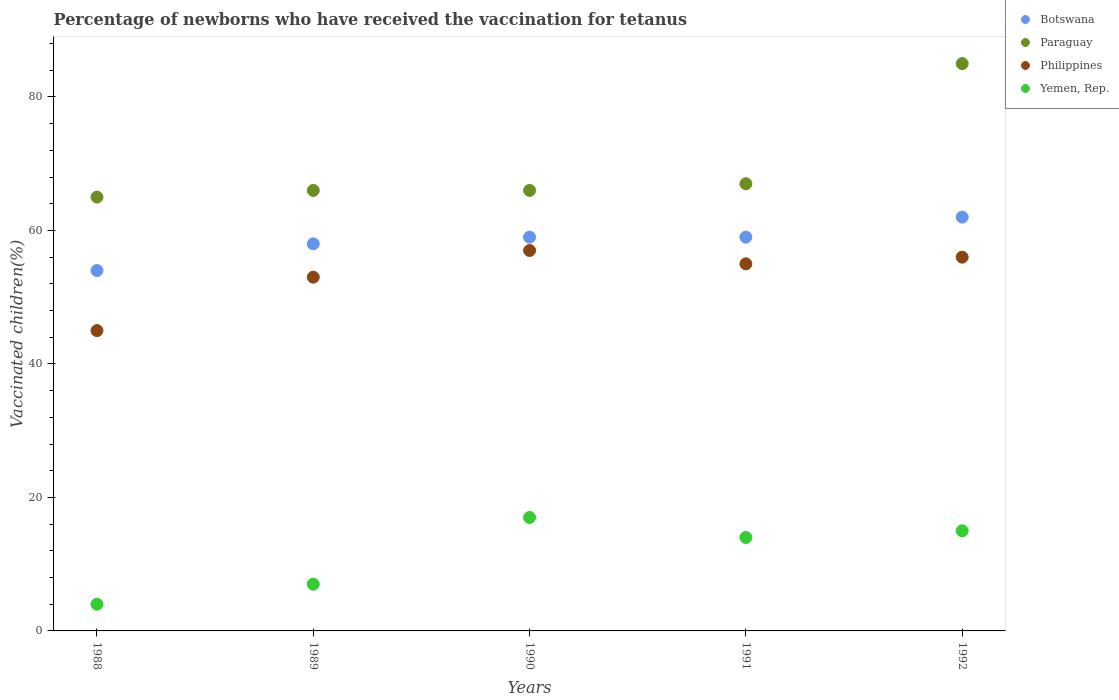Across all years, what is the maximum percentage of vaccinated children in Philippines?
Offer a terse response. 57. Across all years, what is the minimum percentage of vaccinated children in Paraguay?
Your response must be concise. 65. In which year was the percentage of vaccinated children in Philippines maximum?
Your answer should be compact. 1990. In which year was the percentage of vaccinated children in Botswana minimum?
Make the answer very short. 1988. What is the total percentage of vaccinated children in Philippines in the graph?
Give a very brief answer. 266. What is the difference between the percentage of vaccinated children in Philippines in 1988 and that in 1992?
Keep it short and to the point. -11. What is the difference between the percentage of vaccinated children in Paraguay in 1988 and the percentage of vaccinated children in Yemen, Rep. in 1992?
Keep it short and to the point. 50. What is the average percentage of vaccinated children in Philippines per year?
Provide a succinct answer. 53.2. What is the ratio of the percentage of vaccinated children in Botswana in 1988 to that in 1989?
Offer a very short reply. 0.93. What is the difference between the highest and the second highest percentage of vaccinated children in Yemen, Rep.?
Your answer should be very brief. 2. What is the difference between the highest and the lowest percentage of vaccinated children in Yemen, Rep.?
Your response must be concise. 13. In how many years, is the percentage of vaccinated children in Botswana greater than the average percentage of vaccinated children in Botswana taken over all years?
Your answer should be very brief. 3. Is it the case that in every year, the sum of the percentage of vaccinated children in Yemen, Rep. and percentage of vaccinated children in Botswana  is greater than the sum of percentage of vaccinated children in Paraguay and percentage of vaccinated children in Philippines?
Your answer should be compact. No. Is it the case that in every year, the sum of the percentage of vaccinated children in Paraguay and percentage of vaccinated children in Philippines  is greater than the percentage of vaccinated children in Botswana?
Provide a short and direct response. Yes. Does the percentage of vaccinated children in Paraguay monotonically increase over the years?
Offer a terse response. No. Is the percentage of vaccinated children in Paraguay strictly less than the percentage of vaccinated children in Botswana over the years?
Make the answer very short. No. How many years are there in the graph?
Provide a succinct answer. 5. Are the values on the major ticks of Y-axis written in scientific E-notation?
Give a very brief answer. No. Does the graph contain grids?
Ensure brevity in your answer.  No. What is the title of the graph?
Ensure brevity in your answer.  Percentage of newborns who have received the vaccination for tetanus. What is the label or title of the Y-axis?
Make the answer very short. Vaccinated children(%). What is the Vaccinated children(%) of Paraguay in 1988?
Make the answer very short. 65. What is the Vaccinated children(%) of Philippines in 1988?
Keep it short and to the point. 45. What is the Vaccinated children(%) in Yemen, Rep. in 1988?
Offer a terse response. 4. What is the Vaccinated children(%) of Paraguay in 1989?
Ensure brevity in your answer.  66. What is the Vaccinated children(%) of Philippines in 1989?
Provide a short and direct response. 53. What is the Vaccinated children(%) in Yemen, Rep. in 1989?
Provide a short and direct response. 7. What is the Vaccinated children(%) in Philippines in 1990?
Your answer should be very brief. 57. What is the Vaccinated children(%) in Botswana in 1991?
Offer a terse response. 59. What is the Vaccinated children(%) of Paraguay in 1991?
Offer a very short reply. 67. What is the Vaccinated children(%) of Philippines in 1991?
Give a very brief answer. 55. What is the Vaccinated children(%) of Yemen, Rep. in 1991?
Offer a very short reply. 14. What is the Vaccinated children(%) in Botswana in 1992?
Offer a very short reply. 62. What is the Vaccinated children(%) in Paraguay in 1992?
Keep it short and to the point. 85. Across all years, what is the maximum Vaccinated children(%) of Philippines?
Your answer should be compact. 57. Across all years, what is the minimum Vaccinated children(%) of Philippines?
Ensure brevity in your answer.  45. Across all years, what is the minimum Vaccinated children(%) of Yemen, Rep.?
Your answer should be very brief. 4. What is the total Vaccinated children(%) in Botswana in the graph?
Provide a succinct answer. 292. What is the total Vaccinated children(%) of Paraguay in the graph?
Ensure brevity in your answer.  349. What is the total Vaccinated children(%) in Philippines in the graph?
Your answer should be compact. 266. What is the total Vaccinated children(%) of Yemen, Rep. in the graph?
Give a very brief answer. 57. What is the difference between the Vaccinated children(%) in Paraguay in 1988 and that in 1989?
Keep it short and to the point. -1. What is the difference between the Vaccinated children(%) in Philippines in 1988 and that in 1989?
Keep it short and to the point. -8. What is the difference between the Vaccinated children(%) of Botswana in 1988 and that in 1990?
Make the answer very short. -5. What is the difference between the Vaccinated children(%) of Paraguay in 1988 and that in 1991?
Give a very brief answer. -2. What is the difference between the Vaccinated children(%) of Yemen, Rep. in 1988 and that in 1991?
Ensure brevity in your answer.  -10. What is the difference between the Vaccinated children(%) in Botswana in 1988 and that in 1992?
Your answer should be compact. -8. What is the difference between the Vaccinated children(%) of Paraguay in 1988 and that in 1992?
Your answer should be very brief. -20. What is the difference between the Vaccinated children(%) of Philippines in 1988 and that in 1992?
Offer a very short reply. -11. What is the difference between the Vaccinated children(%) in Yemen, Rep. in 1988 and that in 1992?
Ensure brevity in your answer.  -11. What is the difference between the Vaccinated children(%) of Botswana in 1989 and that in 1991?
Your response must be concise. -1. What is the difference between the Vaccinated children(%) of Philippines in 1989 and that in 1991?
Ensure brevity in your answer.  -2. What is the difference between the Vaccinated children(%) of Yemen, Rep. in 1989 and that in 1991?
Provide a succinct answer. -7. What is the difference between the Vaccinated children(%) of Botswana in 1989 and that in 1992?
Offer a very short reply. -4. What is the difference between the Vaccinated children(%) of Paraguay in 1989 and that in 1992?
Make the answer very short. -19. What is the difference between the Vaccinated children(%) of Philippines in 1989 and that in 1992?
Provide a succinct answer. -3. What is the difference between the Vaccinated children(%) of Yemen, Rep. in 1989 and that in 1992?
Your answer should be compact. -8. What is the difference between the Vaccinated children(%) in Paraguay in 1990 and that in 1991?
Offer a terse response. -1. What is the difference between the Vaccinated children(%) in Yemen, Rep. in 1990 and that in 1991?
Your response must be concise. 3. What is the difference between the Vaccinated children(%) in Botswana in 1990 and that in 1992?
Provide a short and direct response. -3. What is the difference between the Vaccinated children(%) of Philippines in 1990 and that in 1992?
Provide a short and direct response. 1. What is the difference between the Vaccinated children(%) of Yemen, Rep. in 1990 and that in 1992?
Your answer should be compact. 2. What is the difference between the Vaccinated children(%) of Paraguay in 1991 and that in 1992?
Make the answer very short. -18. What is the difference between the Vaccinated children(%) of Philippines in 1991 and that in 1992?
Your response must be concise. -1. What is the difference between the Vaccinated children(%) in Botswana in 1988 and the Vaccinated children(%) in Yemen, Rep. in 1989?
Keep it short and to the point. 47. What is the difference between the Vaccinated children(%) in Philippines in 1988 and the Vaccinated children(%) in Yemen, Rep. in 1989?
Give a very brief answer. 38. What is the difference between the Vaccinated children(%) of Botswana in 1988 and the Vaccinated children(%) of Philippines in 1990?
Offer a terse response. -3. What is the difference between the Vaccinated children(%) in Paraguay in 1988 and the Vaccinated children(%) in Philippines in 1990?
Keep it short and to the point. 8. What is the difference between the Vaccinated children(%) in Paraguay in 1988 and the Vaccinated children(%) in Yemen, Rep. in 1990?
Give a very brief answer. 48. What is the difference between the Vaccinated children(%) in Paraguay in 1988 and the Vaccinated children(%) in Philippines in 1991?
Give a very brief answer. 10. What is the difference between the Vaccinated children(%) of Paraguay in 1988 and the Vaccinated children(%) of Yemen, Rep. in 1991?
Provide a short and direct response. 51. What is the difference between the Vaccinated children(%) in Philippines in 1988 and the Vaccinated children(%) in Yemen, Rep. in 1991?
Provide a short and direct response. 31. What is the difference between the Vaccinated children(%) of Botswana in 1988 and the Vaccinated children(%) of Paraguay in 1992?
Ensure brevity in your answer.  -31. What is the difference between the Vaccinated children(%) of Botswana in 1988 and the Vaccinated children(%) of Philippines in 1992?
Keep it short and to the point. -2. What is the difference between the Vaccinated children(%) in Botswana in 1988 and the Vaccinated children(%) in Yemen, Rep. in 1992?
Offer a terse response. 39. What is the difference between the Vaccinated children(%) of Botswana in 1989 and the Vaccinated children(%) of Paraguay in 1990?
Keep it short and to the point. -8. What is the difference between the Vaccinated children(%) of Botswana in 1989 and the Vaccinated children(%) of Yemen, Rep. in 1990?
Provide a succinct answer. 41. What is the difference between the Vaccinated children(%) in Philippines in 1989 and the Vaccinated children(%) in Yemen, Rep. in 1990?
Provide a short and direct response. 36. What is the difference between the Vaccinated children(%) of Botswana in 1989 and the Vaccinated children(%) of Philippines in 1991?
Make the answer very short. 3. What is the difference between the Vaccinated children(%) of Paraguay in 1989 and the Vaccinated children(%) of Yemen, Rep. in 1991?
Give a very brief answer. 52. What is the difference between the Vaccinated children(%) in Botswana in 1989 and the Vaccinated children(%) in Paraguay in 1992?
Offer a terse response. -27. What is the difference between the Vaccinated children(%) in Botswana in 1989 and the Vaccinated children(%) in Yemen, Rep. in 1992?
Make the answer very short. 43. What is the difference between the Vaccinated children(%) in Paraguay in 1989 and the Vaccinated children(%) in Philippines in 1992?
Offer a very short reply. 10. What is the difference between the Vaccinated children(%) in Paraguay in 1989 and the Vaccinated children(%) in Yemen, Rep. in 1992?
Provide a succinct answer. 51. What is the difference between the Vaccinated children(%) in Philippines in 1989 and the Vaccinated children(%) in Yemen, Rep. in 1992?
Keep it short and to the point. 38. What is the difference between the Vaccinated children(%) in Botswana in 1990 and the Vaccinated children(%) in Paraguay in 1991?
Your response must be concise. -8. What is the difference between the Vaccinated children(%) of Botswana in 1990 and the Vaccinated children(%) of Philippines in 1991?
Provide a short and direct response. 4. What is the difference between the Vaccinated children(%) in Botswana in 1990 and the Vaccinated children(%) in Yemen, Rep. in 1991?
Your answer should be very brief. 45. What is the difference between the Vaccinated children(%) of Philippines in 1990 and the Vaccinated children(%) of Yemen, Rep. in 1991?
Your answer should be very brief. 43. What is the difference between the Vaccinated children(%) of Botswana in 1990 and the Vaccinated children(%) of Paraguay in 1992?
Your response must be concise. -26. What is the difference between the Vaccinated children(%) of Botswana in 1990 and the Vaccinated children(%) of Yemen, Rep. in 1992?
Offer a very short reply. 44. What is the difference between the Vaccinated children(%) of Philippines in 1991 and the Vaccinated children(%) of Yemen, Rep. in 1992?
Your answer should be very brief. 40. What is the average Vaccinated children(%) in Botswana per year?
Offer a very short reply. 58.4. What is the average Vaccinated children(%) in Paraguay per year?
Provide a short and direct response. 69.8. What is the average Vaccinated children(%) of Philippines per year?
Provide a succinct answer. 53.2. What is the average Vaccinated children(%) in Yemen, Rep. per year?
Ensure brevity in your answer.  11.4. In the year 1988, what is the difference between the Vaccinated children(%) of Botswana and Vaccinated children(%) of Paraguay?
Ensure brevity in your answer.  -11. In the year 1988, what is the difference between the Vaccinated children(%) of Paraguay and Vaccinated children(%) of Philippines?
Keep it short and to the point. 20. In the year 1988, what is the difference between the Vaccinated children(%) of Paraguay and Vaccinated children(%) of Yemen, Rep.?
Offer a terse response. 61. In the year 1989, what is the difference between the Vaccinated children(%) in Botswana and Vaccinated children(%) in Philippines?
Offer a terse response. 5. In the year 1989, what is the difference between the Vaccinated children(%) in Paraguay and Vaccinated children(%) in Yemen, Rep.?
Offer a very short reply. 59. In the year 1989, what is the difference between the Vaccinated children(%) of Philippines and Vaccinated children(%) of Yemen, Rep.?
Your answer should be very brief. 46. In the year 1990, what is the difference between the Vaccinated children(%) of Paraguay and Vaccinated children(%) of Yemen, Rep.?
Offer a terse response. 49. In the year 1991, what is the difference between the Vaccinated children(%) in Botswana and Vaccinated children(%) in Paraguay?
Provide a succinct answer. -8. In the year 1991, what is the difference between the Vaccinated children(%) of Botswana and Vaccinated children(%) of Yemen, Rep.?
Provide a succinct answer. 45. In the year 1991, what is the difference between the Vaccinated children(%) of Philippines and Vaccinated children(%) of Yemen, Rep.?
Give a very brief answer. 41. In the year 1992, what is the difference between the Vaccinated children(%) of Botswana and Vaccinated children(%) of Yemen, Rep.?
Provide a succinct answer. 47. In the year 1992, what is the difference between the Vaccinated children(%) in Paraguay and Vaccinated children(%) in Philippines?
Give a very brief answer. 29. In the year 1992, what is the difference between the Vaccinated children(%) of Paraguay and Vaccinated children(%) of Yemen, Rep.?
Your answer should be very brief. 70. What is the ratio of the Vaccinated children(%) in Paraguay in 1988 to that in 1989?
Your answer should be compact. 0.98. What is the ratio of the Vaccinated children(%) in Philippines in 1988 to that in 1989?
Your response must be concise. 0.85. What is the ratio of the Vaccinated children(%) in Yemen, Rep. in 1988 to that in 1989?
Your answer should be very brief. 0.57. What is the ratio of the Vaccinated children(%) in Botswana in 1988 to that in 1990?
Give a very brief answer. 0.92. What is the ratio of the Vaccinated children(%) in Paraguay in 1988 to that in 1990?
Your answer should be very brief. 0.98. What is the ratio of the Vaccinated children(%) of Philippines in 1988 to that in 1990?
Make the answer very short. 0.79. What is the ratio of the Vaccinated children(%) in Yemen, Rep. in 1988 to that in 1990?
Give a very brief answer. 0.24. What is the ratio of the Vaccinated children(%) of Botswana in 1988 to that in 1991?
Your answer should be compact. 0.92. What is the ratio of the Vaccinated children(%) of Paraguay in 1988 to that in 1991?
Ensure brevity in your answer.  0.97. What is the ratio of the Vaccinated children(%) of Philippines in 1988 to that in 1991?
Your response must be concise. 0.82. What is the ratio of the Vaccinated children(%) in Yemen, Rep. in 1988 to that in 1991?
Your answer should be very brief. 0.29. What is the ratio of the Vaccinated children(%) of Botswana in 1988 to that in 1992?
Offer a terse response. 0.87. What is the ratio of the Vaccinated children(%) of Paraguay in 1988 to that in 1992?
Your answer should be compact. 0.76. What is the ratio of the Vaccinated children(%) of Philippines in 1988 to that in 1992?
Offer a terse response. 0.8. What is the ratio of the Vaccinated children(%) of Yemen, Rep. in 1988 to that in 1992?
Your answer should be compact. 0.27. What is the ratio of the Vaccinated children(%) of Botswana in 1989 to that in 1990?
Give a very brief answer. 0.98. What is the ratio of the Vaccinated children(%) in Philippines in 1989 to that in 1990?
Ensure brevity in your answer.  0.93. What is the ratio of the Vaccinated children(%) of Yemen, Rep. in 1989 to that in 1990?
Keep it short and to the point. 0.41. What is the ratio of the Vaccinated children(%) of Botswana in 1989 to that in 1991?
Provide a short and direct response. 0.98. What is the ratio of the Vaccinated children(%) of Paraguay in 1989 to that in 1991?
Make the answer very short. 0.99. What is the ratio of the Vaccinated children(%) in Philippines in 1989 to that in 1991?
Give a very brief answer. 0.96. What is the ratio of the Vaccinated children(%) of Yemen, Rep. in 1989 to that in 1991?
Provide a short and direct response. 0.5. What is the ratio of the Vaccinated children(%) of Botswana in 1989 to that in 1992?
Your answer should be very brief. 0.94. What is the ratio of the Vaccinated children(%) of Paraguay in 1989 to that in 1992?
Give a very brief answer. 0.78. What is the ratio of the Vaccinated children(%) in Philippines in 1989 to that in 1992?
Your answer should be compact. 0.95. What is the ratio of the Vaccinated children(%) in Yemen, Rep. in 1989 to that in 1992?
Provide a short and direct response. 0.47. What is the ratio of the Vaccinated children(%) of Paraguay in 1990 to that in 1991?
Your answer should be compact. 0.99. What is the ratio of the Vaccinated children(%) in Philippines in 1990 to that in 1991?
Provide a short and direct response. 1.04. What is the ratio of the Vaccinated children(%) in Yemen, Rep. in 1990 to that in 1991?
Offer a very short reply. 1.21. What is the ratio of the Vaccinated children(%) in Botswana in 1990 to that in 1992?
Make the answer very short. 0.95. What is the ratio of the Vaccinated children(%) of Paraguay in 1990 to that in 1992?
Your answer should be compact. 0.78. What is the ratio of the Vaccinated children(%) of Philippines in 1990 to that in 1992?
Make the answer very short. 1.02. What is the ratio of the Vaccinated children(%) of Yemen, Rep. in 1990 to that in 1992?
Ensure brevity in your answer.  1.13. What is the ratio of the Vaccinated children(%) of Botswana in 1991 to that in 1992?
Keep it short and to the point. 0.95. What is the ratio of the Vaccinated children(%) of Paraguay in 1991 to that in 1992?
Offer a terse response. 0.79. What is the ratio of the Vaccinated children(%) in Philippines in 1991 to that in 1992?
Provide a short and direct response. 0.98. What is the difference between the highest and the second highest Vaccinated children(%) of Botswana?
Make the answer very short. 3. What is the difference between the highest and the second highest Vaccinated children(%) of Philippines?
Provide a short and direct response. 1. What is the difference between the highest and the second highest Vaccinated children(%) in Yemen, Rep.?
Keep it short and to the point. 2. What is the difference between the highest and the lowest Vaccinated children(%) in Botswana?
Your answer should be compact. 8. What is the difference between the highest and the lowest Vaccinated children(%) in Paraguay?
Offer a terse response. 20. What is the difference between the highest and the lowest Vaccinated children(%) in Philippines?
Your answer should be compact. 12. What is the difference between the highest and the lowest Vaccinated children(%) in Yemen, Rep.?
Keep it short and to the point. 13. 